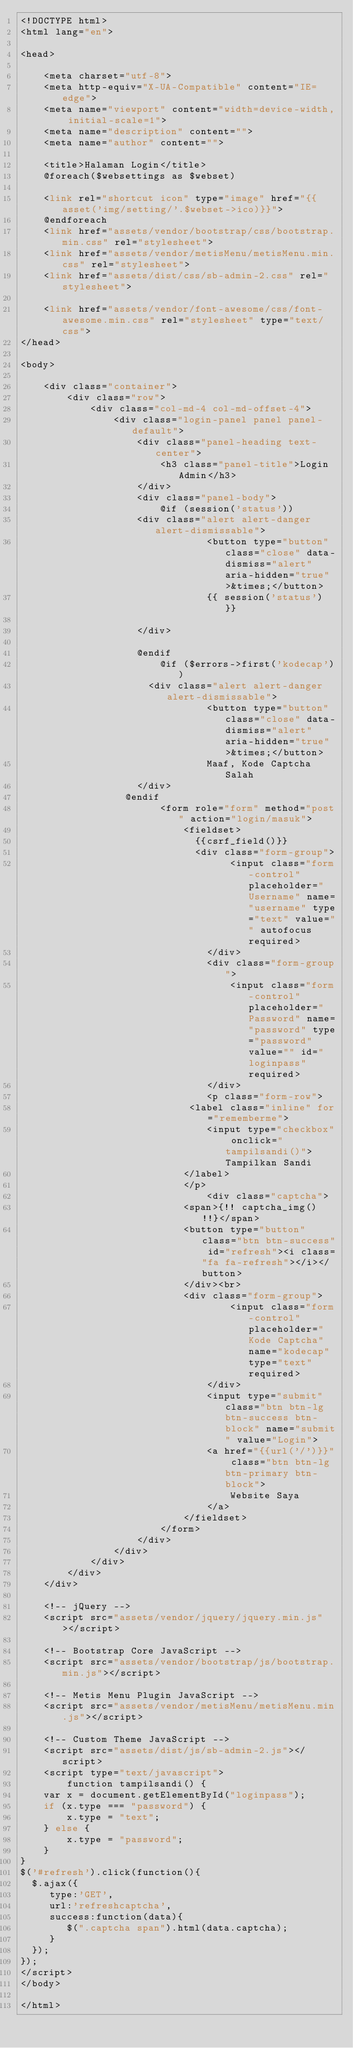Convert code to text. <code><loc_0><loc_0><loc_500><loc_500><_PHP_><!DOCTYPE html>
<html lang="en">

<head>

    <meta charset="utf-8">
    <meta http-equiv="X-UA-Compatible" content="IE=edge">
    <meta name="viewport" content="width=device-width, initial-scale=1">
    <meta name="description" content="">
    <meta name="author" content="">

    <title>Halaman Login</title>
    @foreach($websettings as $webset)
    
    <link rel="shortcut icon" type="image" href="{{asset('img/setting/'.$webset->ico)}}">
    @endforeach
    <link href="assets/vendor/bootstrap/css/bootstrap.min.css" rel="stylesheet">
    <link href="assets/vendor/metisMenu/metisMenu.min.css" rel="stylesheet">
    <link href="assets/dist/css/sb-admin-2.css" rel="stylesheet">
    
    <link href="assets/vendor/font-awesome/css/font-awesome.min.css" rel="stylesheet" type="text/css">
</head>

<body>

    <div class="container">
        <div class="row">
            <div class="col-md-4 col-md-offset-4">
                <div class="login-panel panel panel-default">
                    <div class="panel-heading text-center">
                        <h3 class="panel-title">Login Admin</h3>
                    </div>
                    <div class="panel-body">
                        @if (session('status'))
                    <div class="alert alert-danger alert-dismissable">
                                <button type="button" class="close" data-dismiss="alert" aria-hidden="true">&times;</button>
                                {{ session('status') }}

                    </div>
                    
                    @endif
                        @if ($errors->first('kodecap'))
                      <div class="alert alert-danger alert-dismissable">
                                <button type="button" class="close" data-dismiss="alert" aria-hidden="true">&times;</button>
                                Maaf, Kode Captcha Salah
                    </div>
                  @endif
                        <form role="form" method="post" action="login/masuk">
                            <fieldset>
                            	{{csrf_field()}}
                            	<div class="form-group">
                                    <input class="form-control" placeholder="Username" name="username" type="text" value="" autofocus required>
                                </div>
                                <div class="form-group">
                                    <input class="form-control" placeholder="Password" name="password" type="password" value="" id="loginpass" required>
                                </div>
                                <p class="form-row">
                             <label class="inline" for="rememberme">
                                <input type="checkbox" onclick="tampilsandi()"> Tampilkan Sandi
                            </label>
                            </p>
                                <div class="captcha">
                            <span>{!! captcha_img() !!}</span>
                            <button type="button" class="btn btn-success" id="refresh"><i class="fa fa-refresh"></i></button>
                            </div><br>
                            <div class="form-group">
                                    <input class="form-control" placeholder="Kode Captcha" name="kodecap" type="text" required>
                                </div>
                                <input type="submit" class="btn btn-lg btn-success btn-block" name="submit" value="Login">
                                <a href="{{url('/')}}" class="btn btn-lg btn-primary btn-block">
                                    Website Saya
                                </a>
                            </fieldset>
                        </form>
                    </div>
                </div>
            </div>
        </div>
    </div>

    <!-- jQuery -->
    <script src="assets/vendor/jquery/jquery.min.js"></script>

    <!-- Bootstrap Core JavaScript -->
    <script src="assets/vendor/bootstrap/js/bootstrap.min.js"></script>

    <!-- Metis Menu Plugin JavaScript -->
    <script src="assets/vendor/metisMenu/metisMenu.min.js"></script>

    <!-- Custom Theme JavaScript -->
    <script src="assets/dist/js/sb-admin-2.js"></script>
    <script type="text/javascript">
        function tampilsandi() {
    var x = document.getElementById("loginpass");
    if (x.type === "password") {
        x.type = "text";
    } else {
        x.type = "password";
    }
}
$('#refresh').click(function(){
  $.ajax({
     type:'GET',
     url:'refreshcaptcha',
     success:function(data){
        $(".captcha span").html(data.captcha);
     }
  });
});
</script>
</body>

</html>
</code> 